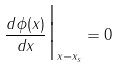<formula> <loc_0><loc_0><loc_500><loc_500>\frac { d \phi ( x ) } { d x } \Big { | } _ { x = x _ { s } } = 0</formula> 